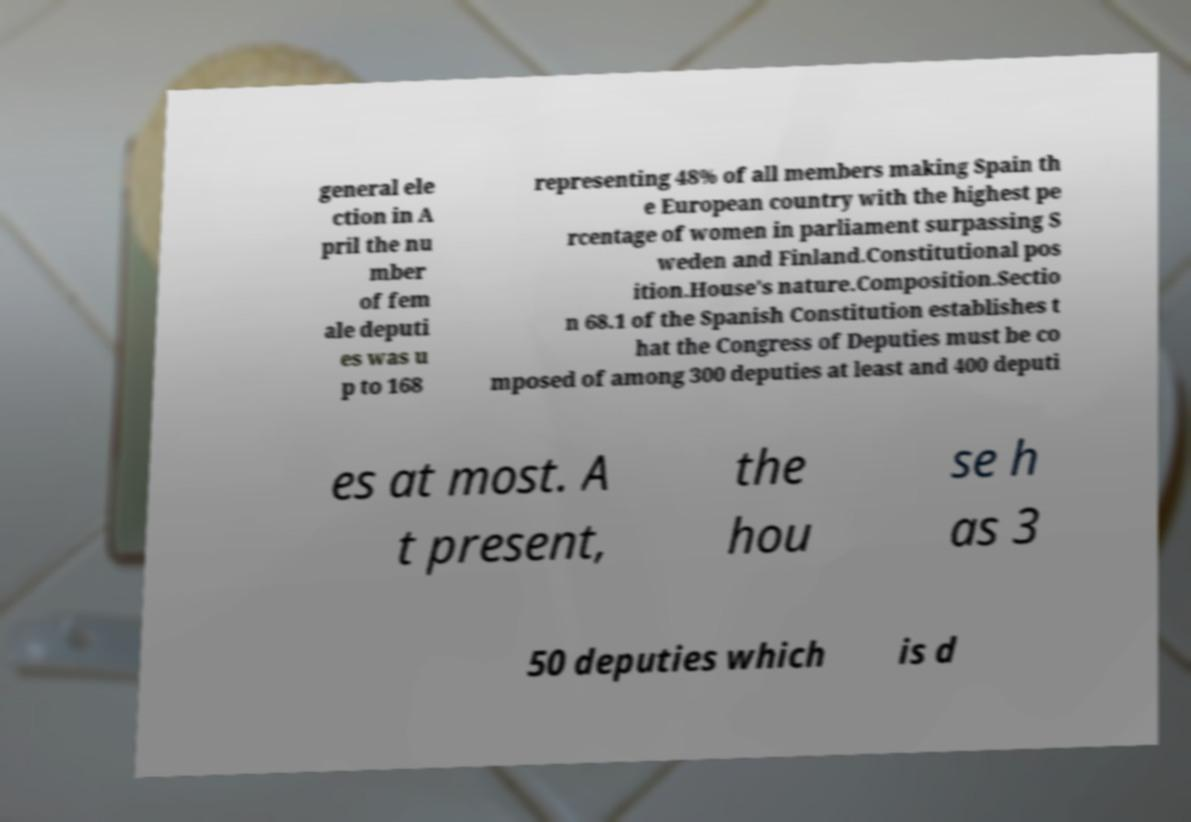Please read and relay the text visible in this image. What does it say? general ele ction in A pril the nu mber of fem ale deputi es was u p to 168 representing 48% of all members making Spain th e European country with the highest pe rcentage of women in parliament surpassing S weden and Finland.Constitutional pos ition.House's nature.Composition.Sectio n 68.1 of the Spanish Constitution establishes t hat the Congress of Deputies must be co mposed of among 300 deputies at least and 400 deputi es at most. A t present, the hou se h as 3 50 deputies which is d 